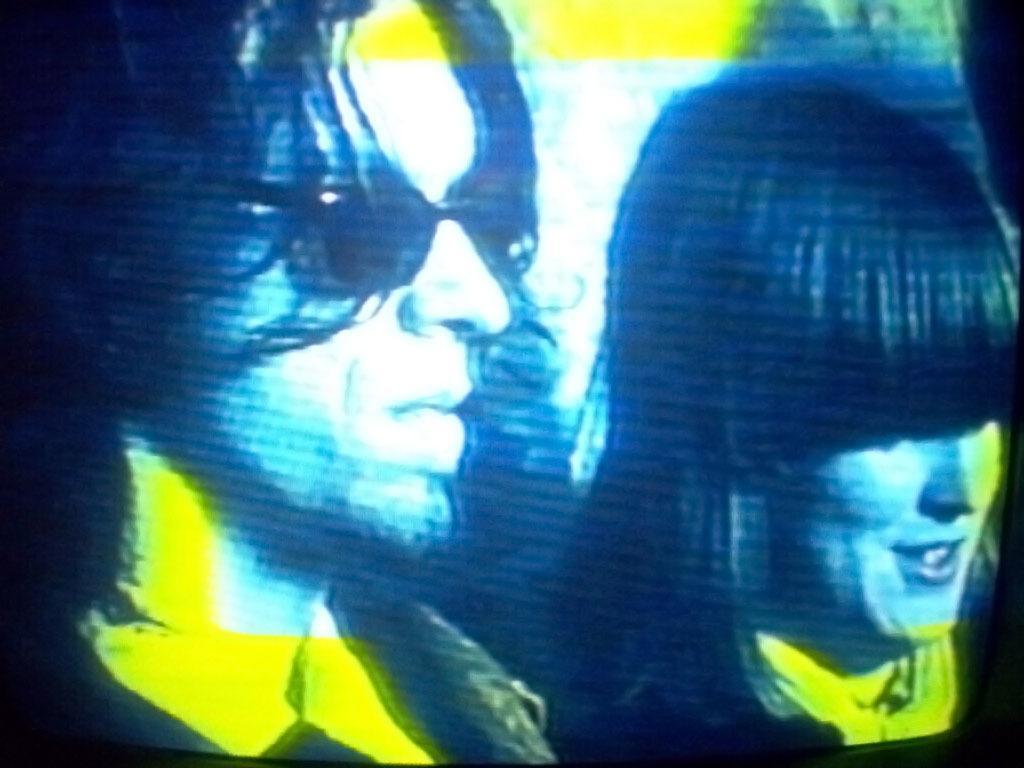Can you describe this image briefly? In this picture, it is looking like a screen and on the screen there are two people. 